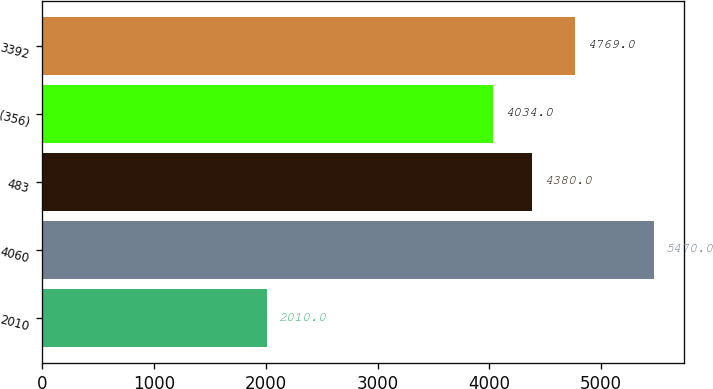Convert chart. <chart><loc_0><loc_0><loc_500><loc_500><bar_chart><fcel>2010<fcel>4060<fcel>483<fcel>(356)<fcel>3392<nl><fcel>2010<fcel>5470<fcel>4380<fcel>4034<fcel>4769<nl></chart> 